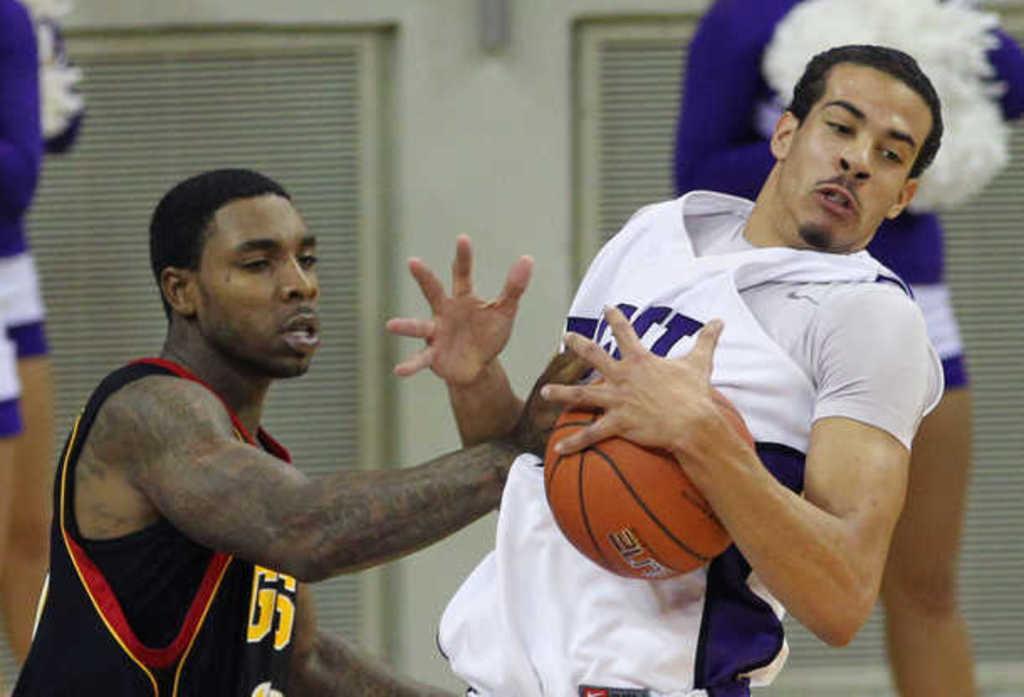Can you describe this image briefly? In this image in the foreground there are two people one person is holding a ball, it seems that they are playing a game. And in the background there are two people, windows and wall. 